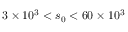<formula> <loc_0><loc_0><loc_500><loc_500>3 \times 1 0 ^ { 3 } < s _ { 0 } < 6 0 \times 1 0 ^ { 3 }</formula> 